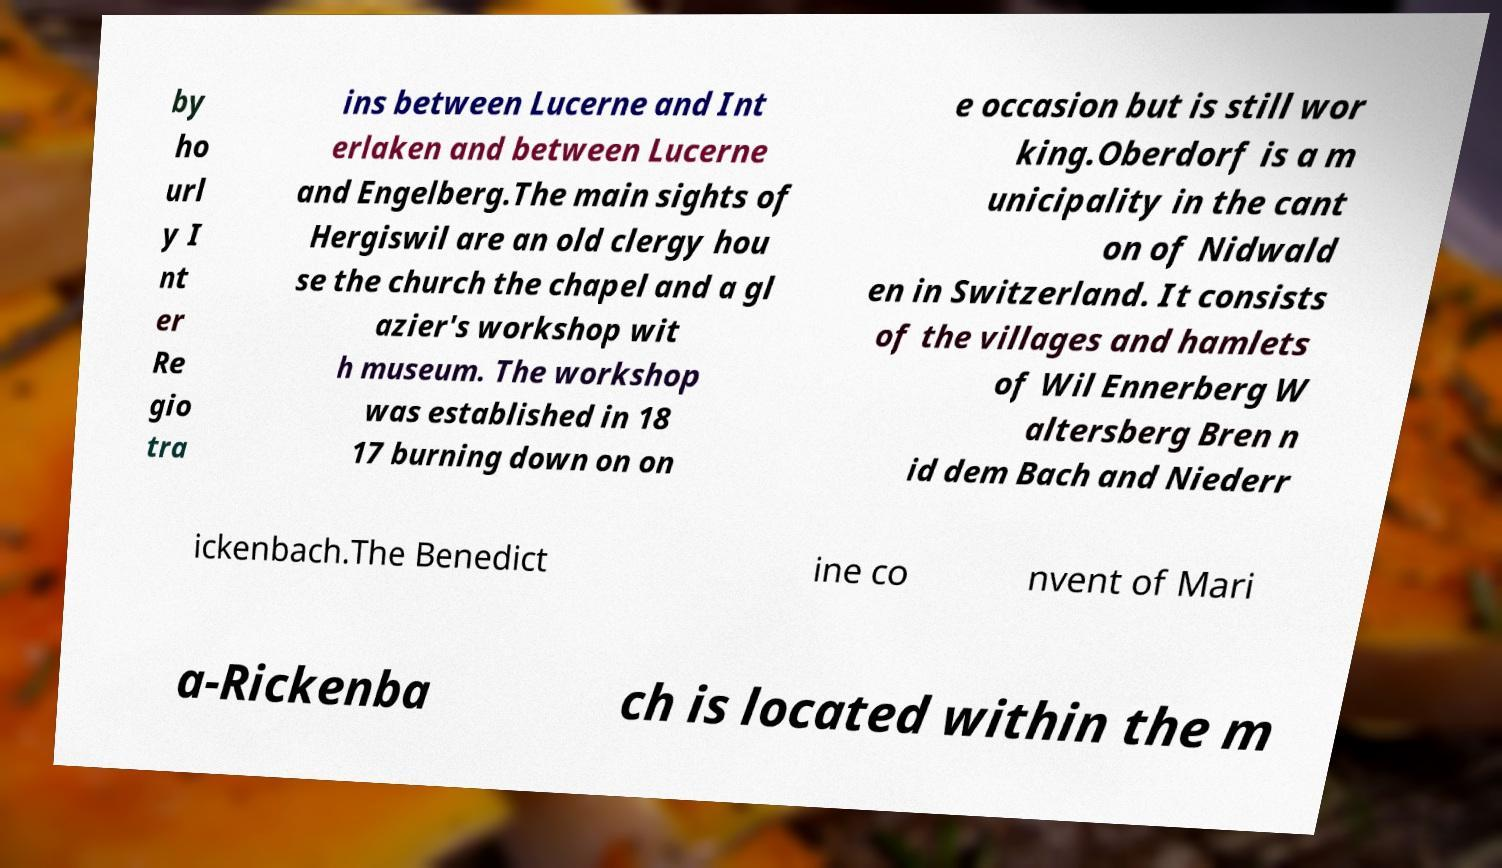Please read and relay the text visible in this image. What does it say? by ho url y I nt er Re gio tra ins between Lucerne and Int erlaken and between Lucerne and Engelberg.The main sights of Hergiswil are an old clergy hou se the church the chapel and a gl azier's workshop wit h museum. The workshop was established in 18 17 burning down on on e occasion but is still wor king.Oberdorf is a m unicipality in the cant on of Nidwald en in Switzerland. It consists of the villages and hamlets of Wil Ennerberg W altersberg Bren n id dem Bach and Niederr ickenbach.The Benedict ine co nvent of Mari a-Rickenba ch is located within the m 